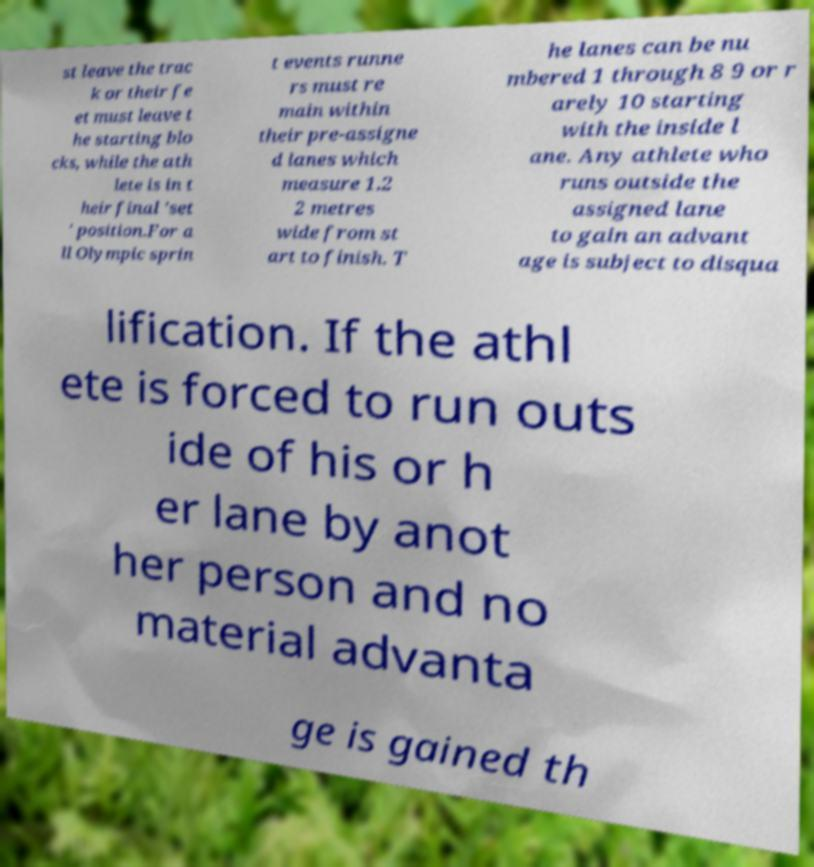What messages or text are displayed in this image? I need them in a readable, typed format. st leave the trac k or their fe et must leave t he starting blo cks, while the ath lete is in t heir final 'set ' position.For a ll Olympic sprin t events runne rs must re main within their pre-assigne d lanes which measure 1.2 2 metres wide from st art to finish. T he lanes can be nu mbered 1 through 8 9 or r arely 10 starting with the inside l ane. Any athlete who runs outside the assigned lane to gain an advant age is subject to disqua lification. If the athl ete is forced to run outs ide of his or h er lane by anot her person and no material advanta ge is gained th 